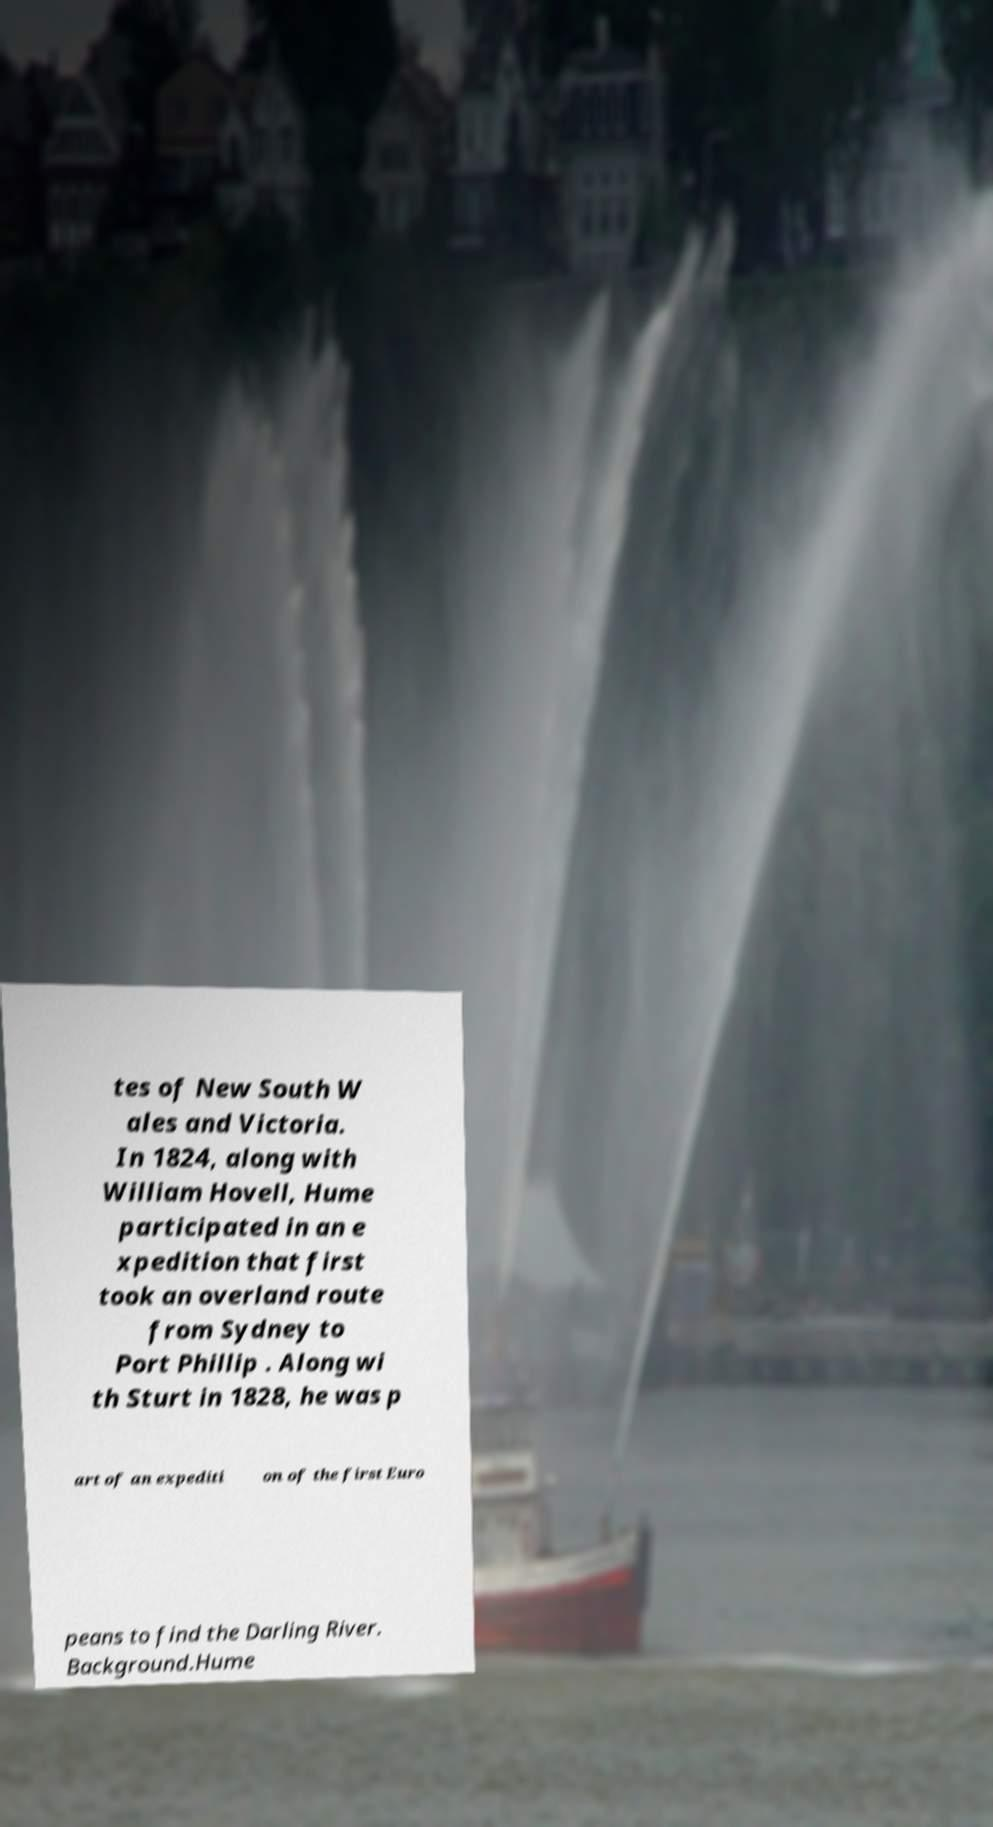What messages or text are displayed in this image? I need them in a readable, typed format. tes of New South W ales and Victoria. In 1824, along with William Hovell, Hume participated in an e xpedition that first took an overland route from Sydney to Port Phillip . Along wi th Sturt in 1828, he was p art of an expediti on of the first Euro peans to find the Darling River. Background.Hume 